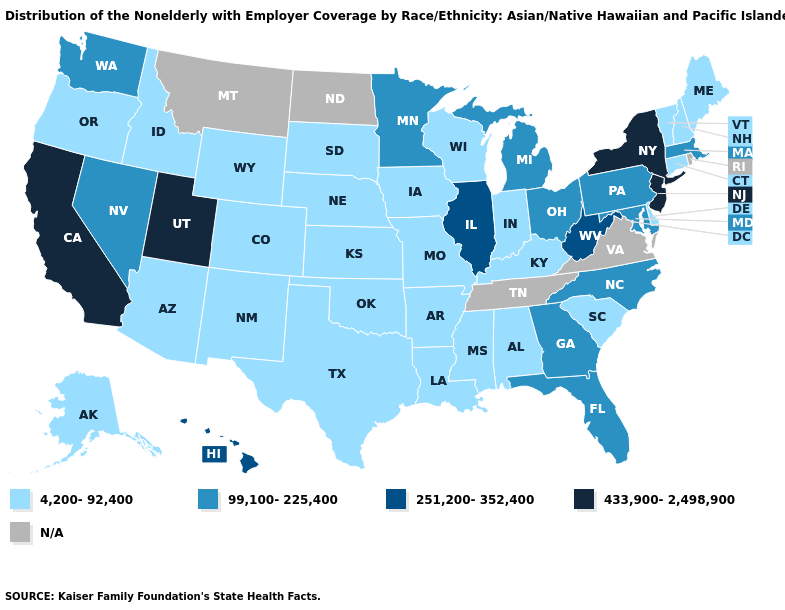Among the states that border Connecticut , which have the highest value?
Quick response, please. New York. How many symbols are there in the legend?
Concise answer only. 5. What is the value of Maine?
Give a very brief answer. 4,200-92,400. Does Pennsylvania have the lowest value in the Northeast?
Quick response, please. No. What is the lowest value in states that border Texas?
Be succinct. 4,200-92,400. What is the highest value in states that border New York?
Answer briefly. 433,900-2,498,900. Does the first symbol in the legend represent the smallest category?
Write a very short answer. Yes. Does the first symbol in the legend represent the smallest category?
Answer briefly. Yes. Among the states that border Virginia , does Maryland have the highest value?
Answer briefly. No. What is the value of Vermont?
Keep it brief. 4,200-92,400. Name the states that have a value in the range 433,900-2,498,900?
Keep it brief. California, New Jersey, New York, Utah. How many symbols are there in the legend?
Answer briefly. 5. 